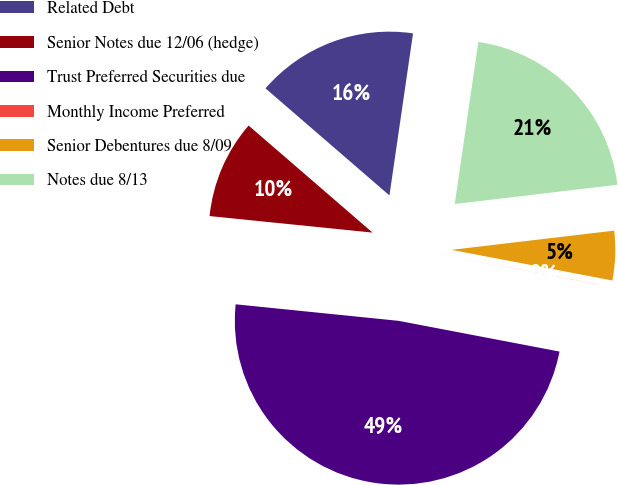<chart> <loc_0><loc_0><loc_500><loc_500><pie_chart><fcel>Related Debt<fcel>Senior Notes due 12/06 (hedge)<fcel>Trust Preferred Securities due<fcel>Monthly Income Preferred<fcel>Senior Debentures due 8/09<fcel>Notes due 8/13<nl><fcel>15.96%<fcel>9.73%<fcel>48.6%<fcel>0.01%<fcel>4.87%<fcel>20.82%<nl></chart> 